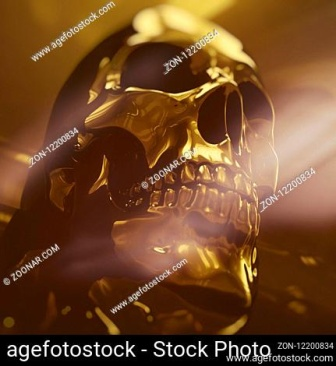Analyze the image in a comprehensive and detailed manner. The image presents a striking close-up of a gold skull set against a stark black background. This skull, with its shiny and smooth texture, stands as the sole focus of the frame. Positioned with a slight tilt to the right, the skull faces the viewer directly, creating a dynamic visual effect in an otherwise static image.

Illuminated from the top left corner, the bright light accentuates the skull's contours, casting a dramatic shadow on its right side and enhancing its three-dimensional appearance. This interplay of light and shadow serves to highlight the intricate details and the metallic gleam of the skull.

In the bottom right corner of the image, there is a watermark reading 'agefotostock - Stock Photo - ZON-12200834', indicating the source of the image. While the watermark is present, it remains small and unobtrusive, not detracting significantly from the overall visual impact.

Overall, the image is a study in contrasts and themes: the gleaming gold of the skull against the deep black background, the interplay of light and shadow, and the juxtaposition of the skull, symbolizing both death and artistry, within the stillness of the image. It is a powerful and evocative visual, evoking contemplation and fascination. 